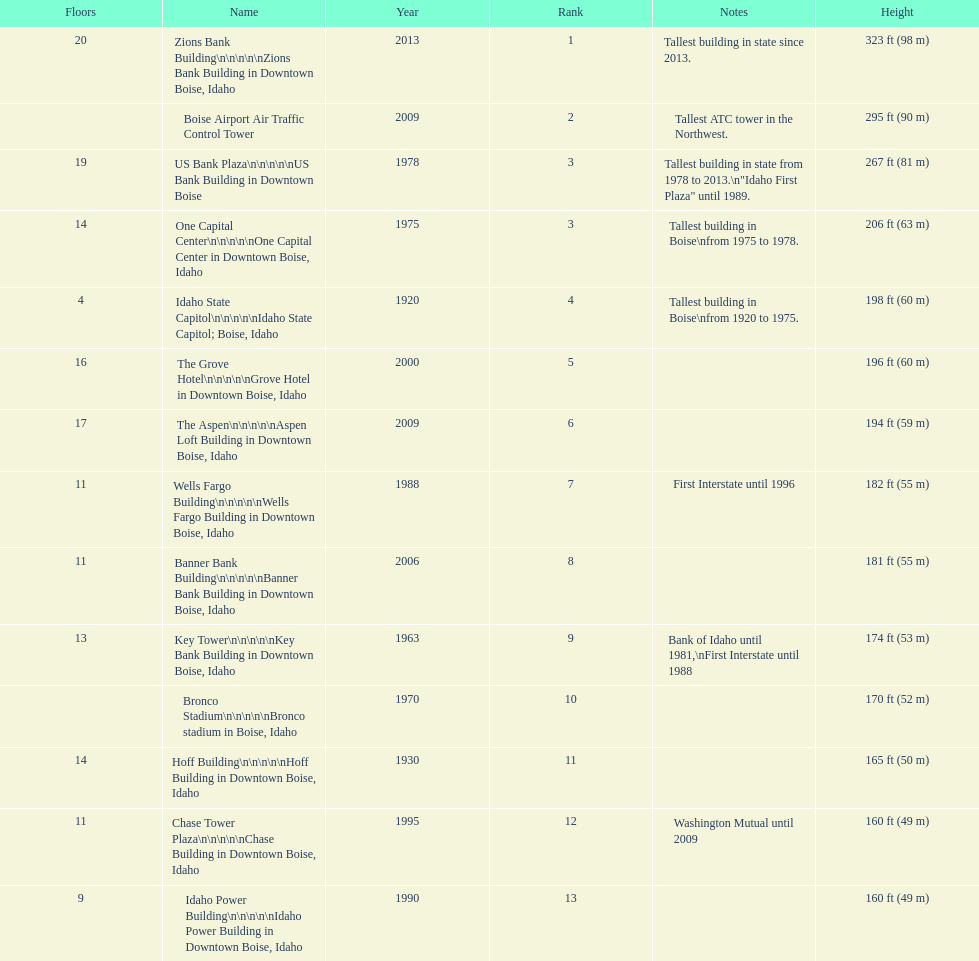How many of these buildings were built after 1975 8. 